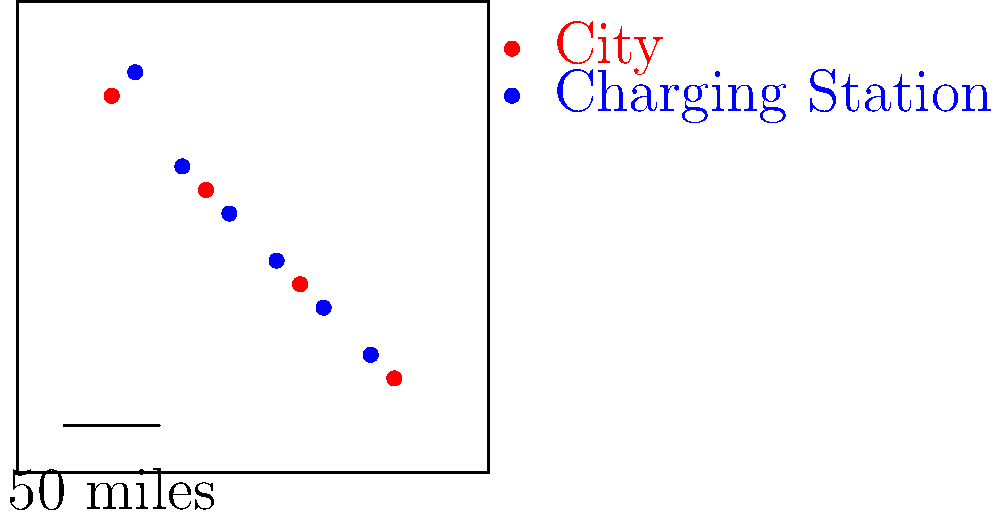Based on the map of electric vehicle charging station locations, what strategy appears to have been used in their placement, and how might this impact the senator's message on clean energy and transportation? To answer this question, let's analyze the map step-by-step:

1. Distribution pattern: The charging stations (blue dots) are spread out across the state, forming a diagonal line from the northwest to the southeast.

2. Relation to cities: Each charging station is located near a city (red dot), but not directly in the city centers.

3. Distances: The charging stations appear to be spaced at regular intervals, approximately 50 miles apart (based on the scale provided).

4. Coverage: This distribution ensures that most areas of the state are within reasonable distance of a charging station.

5. Strategic placement: The stations seem to be placed along a major travel corridor, connecting multiple cities.

This strategy of placement suggests:
a) Accessibility: Ensuring EV drivers can travel across the state without range anxiety.
b) Intercity connectivity: Facilitating long-distance travel between urban centers.
c) Rural access: Providing charging options in less populated areas between cities.

Impact on the senator's message:
1. Demonstrates commitment to statewide clean energy infrastructure.
2. Shows consideration for both urban and rural constituents.
3. Supports the argument that EVs are viable for long-distance travel.
4. Illustrates a systematic approach to encouraging EV adoption.

This placement strategy allows the senator to emphasize how the state is making clean transportation accessible and practical for all residents, supporting both environmental goals and economic development across diverse regions.
Answer: Strategic corridor placement connecting cities, demonstrating statewide commitment to accessible clean transportation 